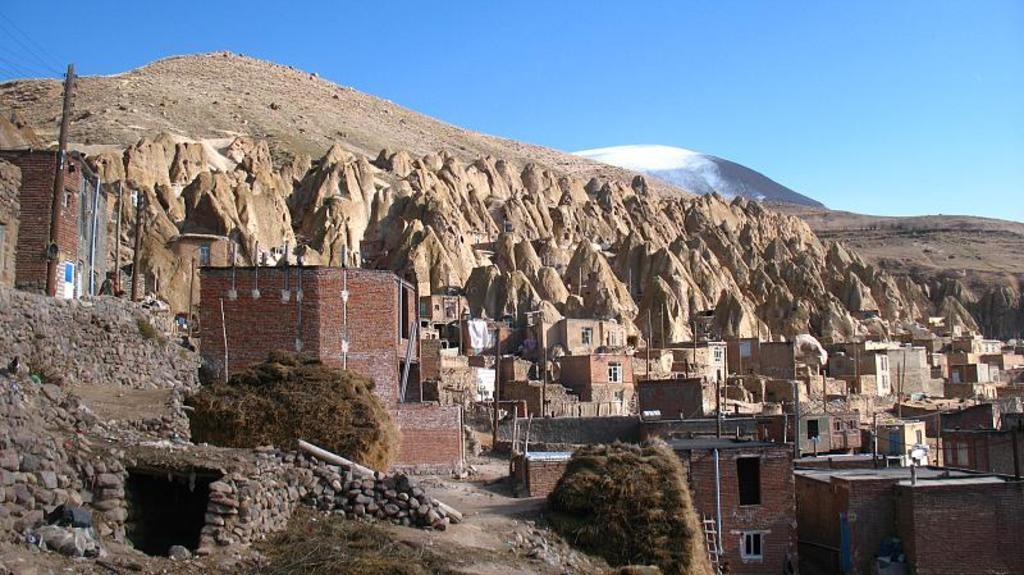Can you describe this image briefly? As we can see in the image there are houses, plants, rocks, buildings and hills. At the top there is sky. 